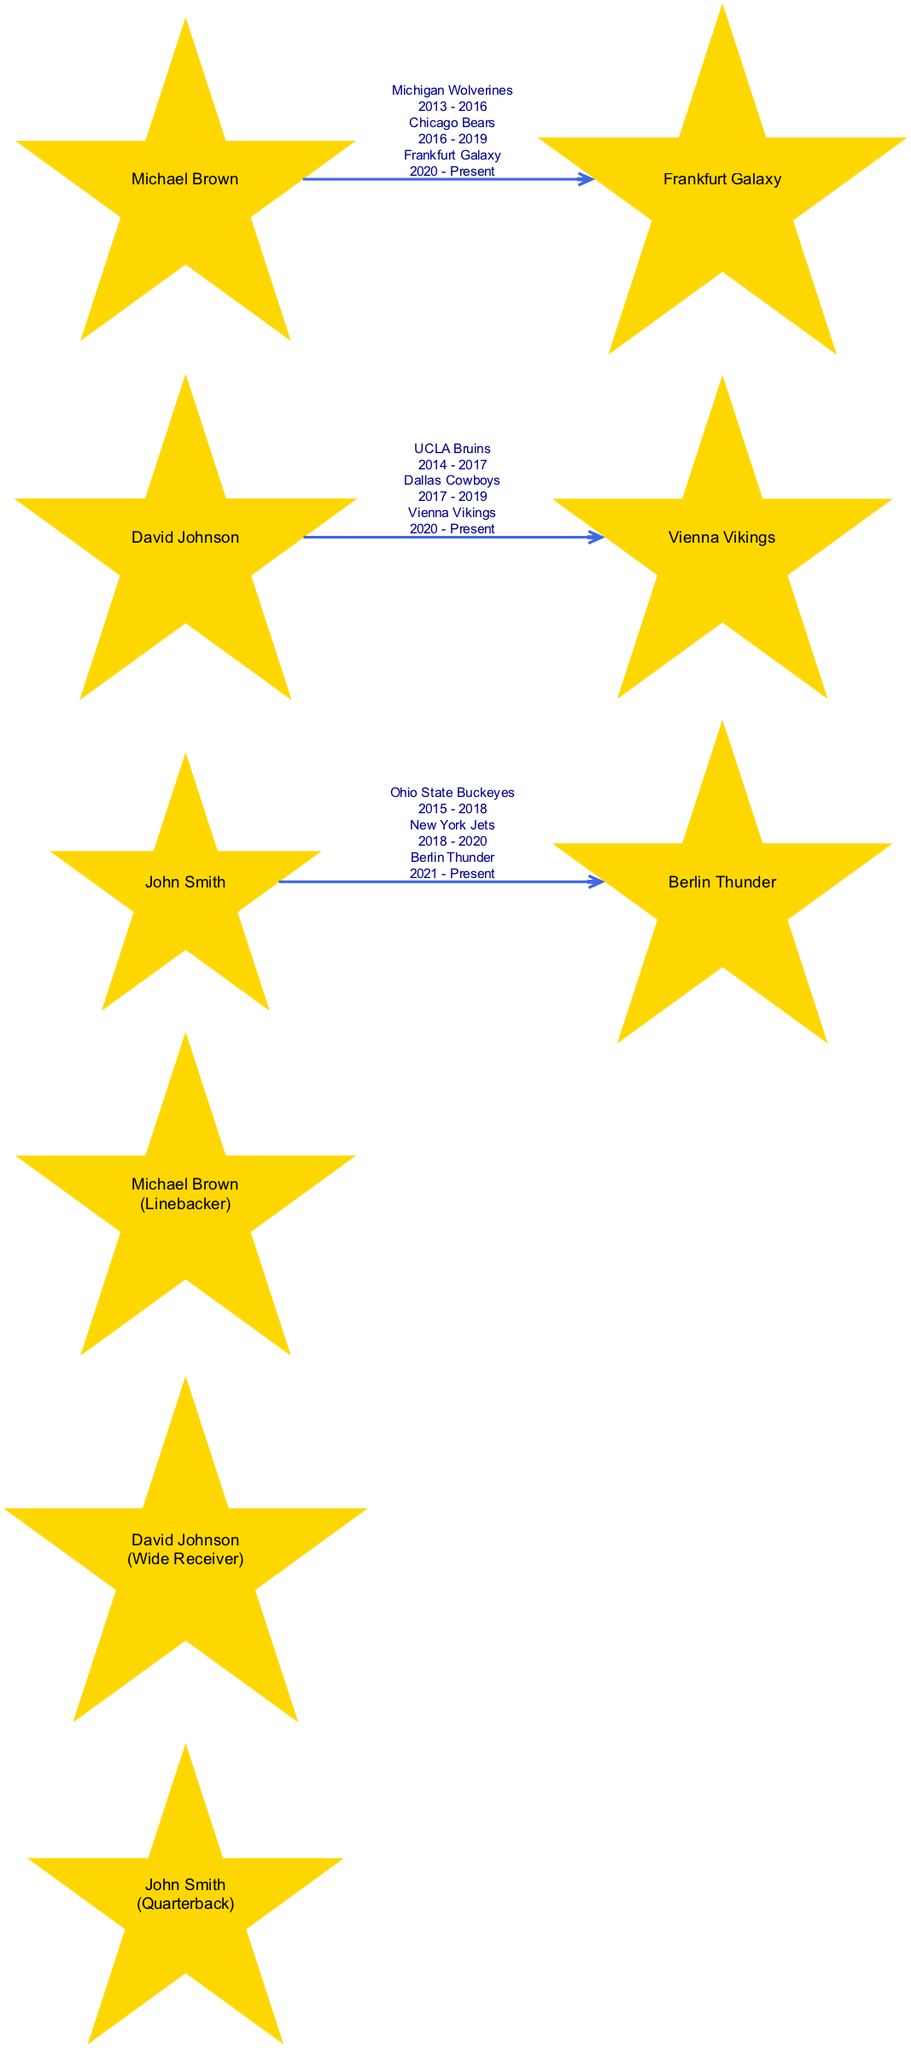What are the current teams of the players? The diagram has three nodes representing three players. Examining each player’s "currentTeam" attribute, John Smith is with Berlin Thunder, David Johnson is with Vienna Vikings, and Michael Brown is with Frankfurt Galaxy.
Answer: Berlin Thunder, Vienna Vikings, Frankfurt Galaxy How many players are represented in the diagram? The diagram has three nodes, each corresponding to a player. Counting these nodes provides the total number of players represented, which is three.
Answer: 3 Which position does Michael Brown play? By checking the node representing Michael Brown, we see the label indicates his position is "Linebacker." This information is derived from Michael Brown’s attributes in the diagram.
Answer: Linebacker What team did John Smith play for before joining Berlin Thunder? The diagram shows John Smith’s career path. It states that he played for the New York Jets prior to joining the Berlin Thunder, as indicated by the sequence of teams listed under his career path.
Answer: New York Jets Which player had the longest duration with a single college team? Analyzing the events for each player, we note that David Johnson played for UCLA Bruins from 2014 to 2017, which spans four years. John Smith and Michael Brown both have a three-year tenure at their college teams. Thus, David Johnson had the longest duration at a single college team.
Answer: UCLA Bruins What is the shortest career span between two teams for any of the players? By examining the duration of each player’s transitions between teams, we find that John Smith transitioned from New York Jets to Berlin Thunder after two years, which is the shortest duration among all transitions in the diagram.
Answer: 2 years How many teams did Michael Brown play for in total? Michael Brown's career path lists three teams: Michigan Wolverines, Chicago Bears, and Frankfurt Galaxy. Counting these gives us a total of three teams he played for in his career.
Answer: 3 What is the common trait of the current teams of the players? All current teams represented in the diagram are associated with European leagues. By looking at the current teams again (Berlin Thunder, Vienna Vikings, and Frankfurt Galaxy) it is clear they are all Euro-American football teams.
Answer: Euro-American football teams Which player transitioned directly from college to a professional league? The diagram indicates that each player transitioned from a college team to a professional league. However, John Smith transitioned from Ohio State Buckeyes directly to the New York Jets in the NFL, which qualifies as direct to a professional league as opposed to an intermediary team.
Answer: John Smith 